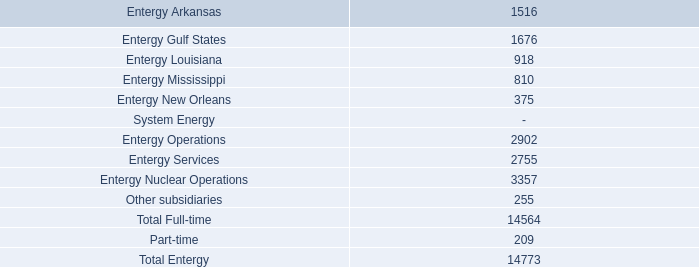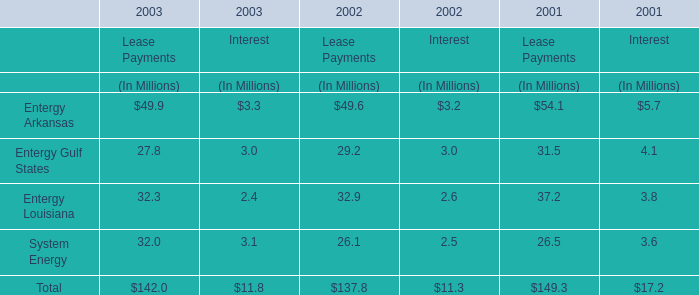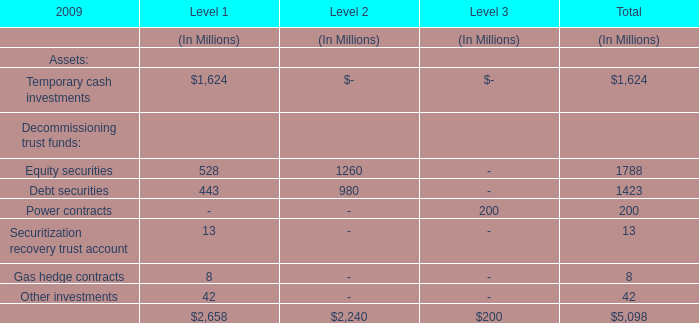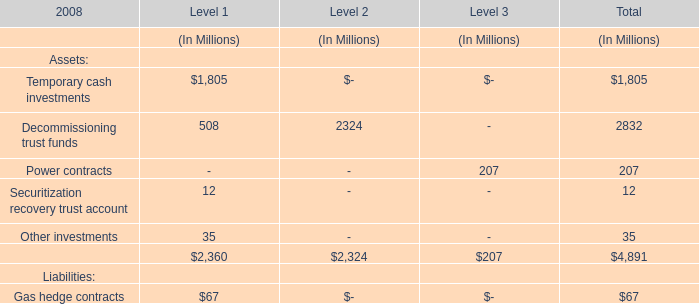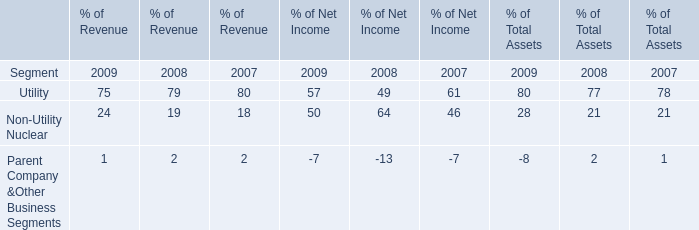In which section the sum of Level 1 has the highest value? (in million) 
Answer: 1805.0. 